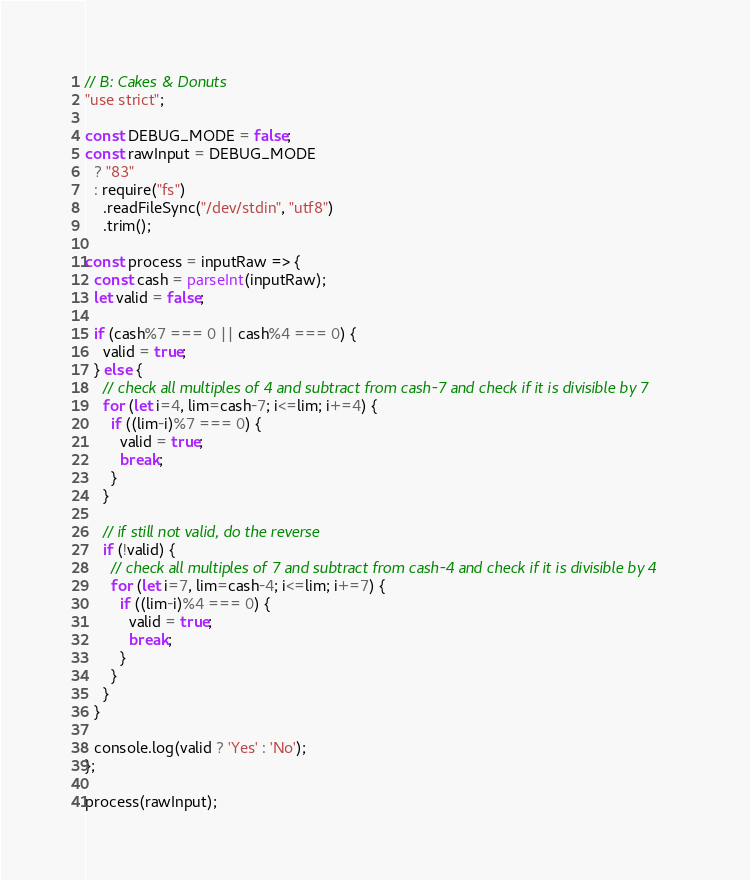Convert code to text. <code><loc_0><loc_0><loc_500><loc_500><_JavaScript_>// B: Cakes & Donuts
"use strict";

const DEBUG_MODE = false;
const rawInput = DEBUG_MODE
  ? "83"
  : require("fs")
    .readFileSync("/dev/stdin", "utf8")
    .trim();

const process = inputRaw => {
  const cash = parseInt(inputRaw);
  let valid = false;

  if (cash%7 === 0 || cash%4 === 0) {
    valid = true;
  } else {
    // check all multiples of 4 and subtract from cash-7 and check if it is divisible by 7
    for (let i=4, lim=cash-7; i<=lim; i+=4) {
      if ((lim-i)%7 === 0) {
        valid = true;
        break;
      }
    }

    // if still not valid, do the reverse
    if (!valid) {
      // check all multiples of 7 and subtract from cash-4 and check if it is divisible by 4
      for (let i=7, lim=cash-4; i<=lim; i+=7) {
        if ((lim-i)%4 === 0) {
          valid = true;
          break;
        }
      }
    }
  }

  console.log(valid ? 'Yes' : 'No');
};

process(rawInput);</code> 